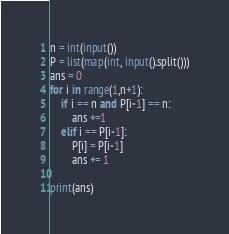<code> <loc_0><loc_0><loc_500><loc_500><_Python_>n = int(input())
P = list(map(int, input().split()))
ans = 0
for i in range(1,n+1):
    if i == n and P[i-1] == n:
        ans +=1
    elif i == P[i-1]:
        P[i] = P[i-1]
        ans += 1

print(ans)

</code> 